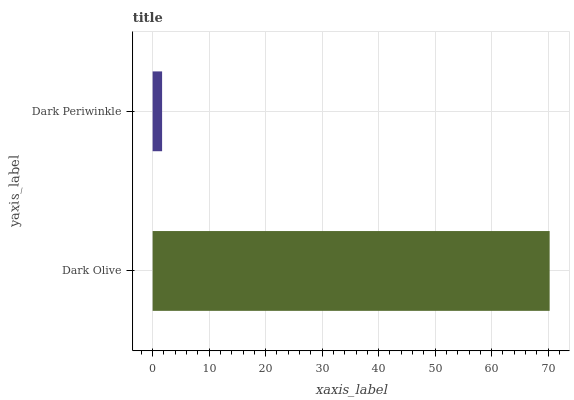Is Dark Periwinkle the minimum?
Answer yes or no. Yes. Is Dark Olive the maximum?
Answer yes or no. Yes. Is Dark Periwinkle the maximum?
Answer yes or no. No. Is Dark Olive greater than Dark Periwinkle?
Answer yes or no. Yes. Is Dark Periwinkle less than Dark Olive?
Answer yes or no. Yes. Is Dark Periwinkle greater than Dark Olive?
Answer yes or no. No. Is Dark Olive less than Dark Periwinkle?
Answer yes or no. No. Is Dark Olive the high median?
Answer yes or no. Yes. Is Dark Periwinkle the low median?
Answer yes or no. Yes. Is Dark Periwinkle the high median?
Answer yes or no. No. Is Dark Olive the low median?
Answer yes or no. No. 